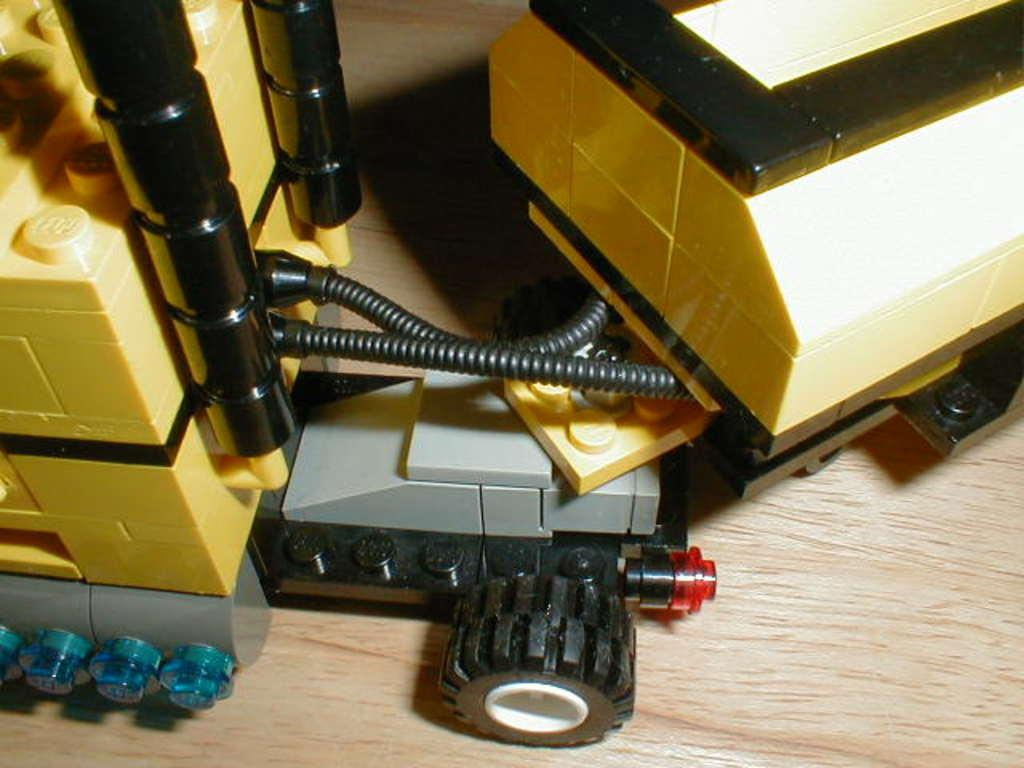What type of toys are in the image? There are lego toys in the image. Can you describe a specific structure made up of lego toys in the image? Yes, there is a trolley made up of lego toys in the image. What type of lace is used to decorate the lego trolley in the image? There is no lace present on the lego trolley in the image. How many feathers are attached to the lego toys in the image? There are no feathers attached to the lego toys in the image. 